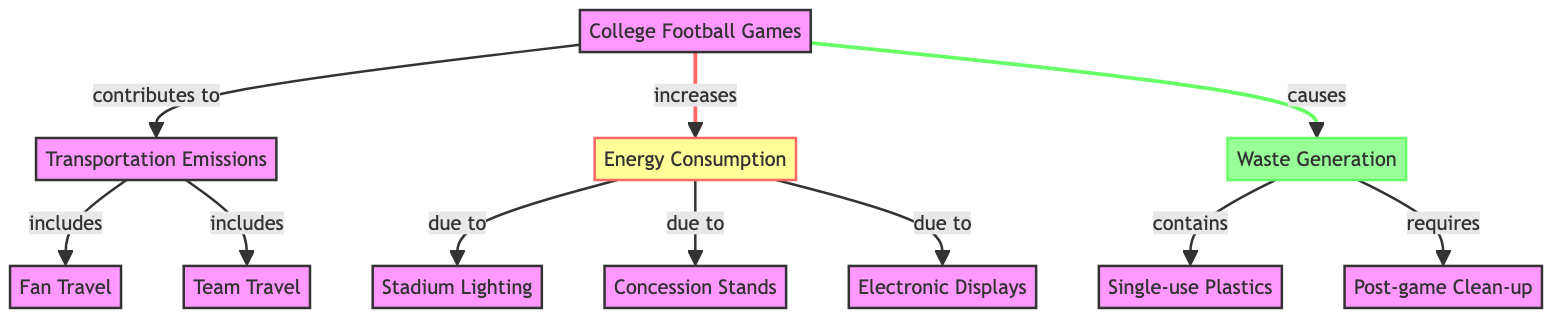What contributes to transportation emissions in college football games? According to the diagram, transportation emissions are contributed to by fan travel and team travel, which are both connected to the transportation emissions node.
Answer: Fan travel and team travel How many nodes are present in the diagram? The diagram has a total of 11 nodes, including College Football Games, Transportation Emissions, Energy Consumption, Waste Generation, and their sub-components.
Answer: 11 What are the two main categories linked directly to college football games? The two main categories linked directly to college football games in the diagram are transportation emissions and energy consumption, as indicated by the direct connections from the main node.
Answer: Transportation emissions and energy consumption What waste is required after the games? The diagram states that post-game clean-up is required after the games, which is clearly linked to the waste generation node.
Answer: Post-game clean-up What is included in energy consumption due to stadium functions? The diagram clearly indicates that stadium lighting, concession stands, and electronic displays contribute to energy consumption, which is a sub-node of the energy consumption node.
Answer: Stadium lighting, concession stands, and electronic displays Which waste component is directly associated with post-game activities? Post-game clean-up is the waste component that is directly associated with activities after the game, as shown in the waste generation node connections.
Answer: Post-game clean-up Which emissions category is linked to both fan and team travel? Transportation emissions encompass both fan travel and team travel, making it the emissions category linked to these two activities according to the diagram.
Answer: Transportation emissions What type of plastics does waste generation include? The diagram specifies that waste generation includes single-use plastics, which is explicitly mentioned as a part of the waste generation node.
Answer: Single-use plastics 